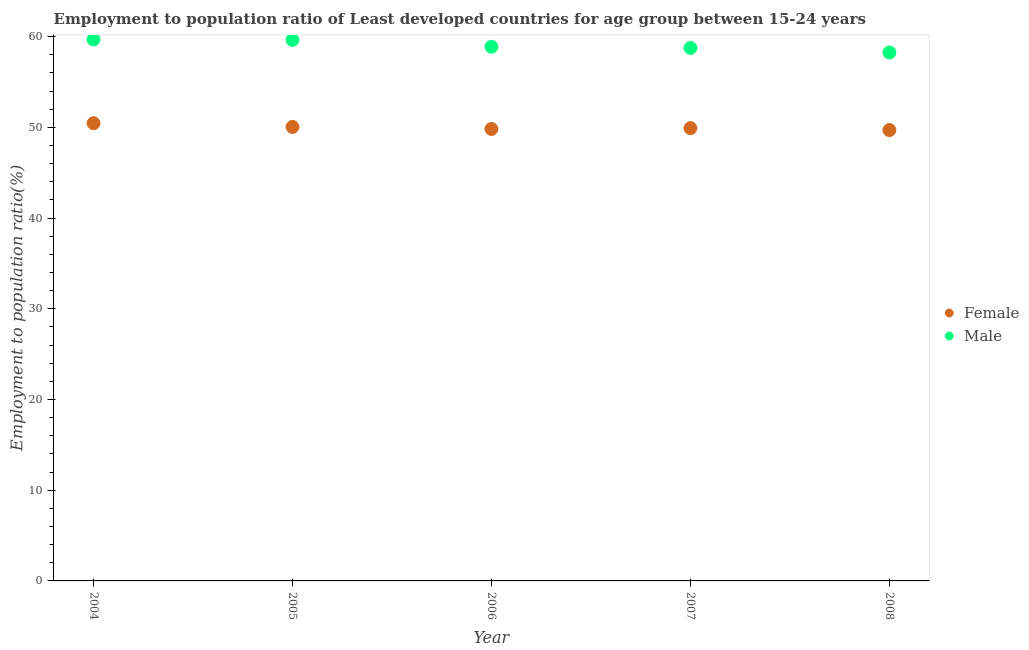How many different coloured dotlines are there?
Provide a succinct answer. 2. Is the number of dotlines equal to the number of legend labels?
Offer a terse response. Yes. What is the employment to population ratio(female) in 2007?
Your answer should be compact. 49.91. Across all years, what is the maximum employment to population ratio(male)?
Your answer should be very brief. 59.69. Across all years, what is the minimum employment to population ratio(female)?
Give a very brief answer. 49.7. What is the total employment to population ratio(female) in the graph?
Keep it short and to the point. 249.92. What is the difference between the employment to population ratio(male) in 2007 and that in 2008?
Give a very brief answer. 0.5. What is the difference between the employment to population ratio(male) in 2004 and the employment to population ratio(female) in 2005?
Keep it short and to the point. 9.65. What is the average employment to population ratio(female) per year?
Offer a terse response. 49.98. In the year 2004, what is the difference between the employment to population ratio(male) and employment to population ratio(female)?
Ensure brevity in your answer.  9.24. What is the ratio of the employment to population ratio(female) in 2004 to that in 2005?
Your answer should be compact. 1.01. Is the employment to population ratio(male) in 2007 less than that in 2008?
Give a very brief answer. No. Is the difference between the employment to population ratio(female) in 2006 and 2008 greater than the difference between the employment to population ratio(male) in 2006 and 2008?
Provide a short and direct response. No. What is the difference between the highest and the second highest employment to population ratio(female)?
Provide a short and direct response. 0.41. What is the difference between the highest and the lowest employment to population ratio(male)?
Give a very brief answer. 1.44. In how many years, is the employment to population ratio(male) greater than the average employment to population ratio(male) taken over all years?
Your response must be concise. 2. Is the employment to population ratio(male) strictly greater than the employment to population ratio(female) over the years?
Your response must be concise. Yes. Is the employment to population ratio(male) strictly less than the employment to population ratio(female) over the years?
Offer a terse response. No. How many dotlines are there?
Make the answer very short. 2. What is the difference between two consecutive major ticks on the Y-axis?
Your answer should be compact. 10. Does the graph contain any zero values?
Provide a short and direct response. No. Does the graph contain grids?
Ensure brevity in your answer.  No. How many legend labels are there?
Ensure brevity in your answer.  2. What is the title of the graph?
Make the answer very short. Employment to population ratio of Least developed countries for age group between 15-24 years. What is the Employment to population ratio(%) of Female in 2004?
Ensure brevity in your answer.  50.45. What is the Employment to population ratio(%) in Male in 2004?
Make the answer very short. 59.69. What is the Employment to population ratio(%) of Female in 2005?
Offer a very short reply. 50.04. What is the Employment to population ratio(%) in Male in 2005?
Provide a succinct answer. 59.64. What is the Employment to population ratio(%) in Female in 2006?
Offer a terse response. 49.82. What is the Employment to population ratio(%) in Male in 2006?
Offer a terse response. 58.88. What is the Employment to population ratio(%) of Female in 2007?
Offer a very short reply. 49.91. What is the Employment to population ratio(%) in Male in 2007?
Your answer should be very brief. 58.75. What is the Employment to population ratio(%) of Female in 2008?
Offer a terse response. 49.7. What is the Employment to population ratio(%) in Male in 2008?
Make the answer very short. 58.25. Across all years, what is the maximum Employment to population ratio(%) of Female?
Provide a short and direct response. 50.45. Across all years, what is the maximum Employment to population ratio(%) of Male?
Ensure brevity in your answer.  59.69. Across all years, what is the minimum Employment to population ratio(%) of Female?
Ensure brevity in your answer.  49.7. Across all years, what is the minimum Employment to population ratio(%) in Male?
Your answer should be compact. 58.25. What is the total Employment to population ratio(%) of Female in the graph?
Provide a succinct answer. 249.92. What is the total Employment to population ratio(%) of Male in the graph?
Provide a succinct answer. 295.2. What is the difference between the Employment to population ratio(%) in Female in 2004 and that in 2005?
Offer a terse response. 0.41. What is the difference between the Employment to population ratio(%) of Male in 2004 and that in 2005?
Offer a terse response. 0.05. What is the difference between the Employment to population ratio(%) of Female in 2004 and that in 2006?
Offer a terse response. 0.63. What is the difference between the Employment to population ratio(%) in Male in 2004 and that in 2006?
Ensure brevity in your answer.  0.81. What is the difference between the Employment to population ratio(%) of Female in 2004 and that in 2007?
Offer a terse response. 0.54. What is the difference between the Employment to population ratio(%) of Female in 2004 and that in 2008?
Offer a very short reply. 0.75. What is the difference between the Employment to population ratio(%) of Male in 2004 and that in 2008?
Offer a very short reply. 1.44. What is the difference between the Employment to population ratio(%) of Female in 2005 and that in 2006?
Keep it short and to the point. 0.22. What is the difference between the Employment to population ratio(%) in Male in 2005 and that in 2006?
Offer a very short reply. 0.76. What is the difference between the Employment to population ratio(%) in Female in 2005 and that in 2007?
Your response must be concise. 0.13. What is the difference between the Employment to population ratio(%) of Male in 2005 and that in 2007?
Your response must be concise. 0.89. What is the difference between the Employment to population ratio(%) in Female in 2005 and that in 2008?
Offer a very short reply. 0.34. What is the difference between the Employment to population ratio(%) of Male in 2005 and that in 2008?
Make the answer very short. 1.4. What is the difference between the Employment to population ratio(%) in Female in 2006 and that in 2007?
Make the answer very short. -0.09. What is the difference between the Employment to population ratio(%) in Male in 2006 and that in 2007?
Offer a very short reply. 0.13. What is the difference between the Employment to population ratio(%) in Female in 2006 and that in 2008?
Offer a very short reply. 0.12. What is the difference between the Employment to population ratio(%) of Male in 2006 and that in 2008?
Provide a succinct answer. 0.63. What is the difference between the Employment to population ratio(%) of Female in 2007 and that in 2008?
Provide a short and direct response. 0.21. What is the difference between the Employment to population ratio(%) of Male in 2007 and that in 2008?
Your answer should be compact. 0.5. What is the difference between the Employment to population ratio(%) in Female in 2004 and the Employment to population ratio(%) in Male in 2005?
Ensure brevity in your answer.  -9.19. What is the difference between the Employment to population ratio(%) of Female in 2004 and the Employment to population ratio(%) of Male in 2006?
Ensure brevity in your answer.  -8.43. What is the difference between the Employment to population ratio(%) in Female in 2004 and the Employment to population ratio(%) in Male in 2007?
Offer a terse response. -8.3. What is the difference between the Employment to population ratio(%) in Female in 2004 and the Employment to population ratio(%) in Male in 2008?
Your answer should be very brief. -7.8. What is the difference between the Employment to population ratio(%) of Female in 2005 and the Employment to population ratio(%) of Male in 2006?
Your answer should be very brief. -8.84. What is the difference between the Employment to population ratio(%) in Female in 2005 and the Employment to population ratio(%) in Male in 2007?
Make the answer very short. -8.71. What is the difference between the Employment to population ratio(%) in Female in 2005 and the Employment to population ratio(%) in Male in 2008?
Provide a short and direct response. -8.2. What is the difference between the Employment to population ratio(%) of Female in 2006 and the Employment to population ratio(%) of Male in 2007?
Give a very brief answer. -8.93. What is the difference between the Employment to population ratio(%) in Female in 2006 and the Employment to population ratio(%) in Male in 2008?
Your answer should be compact. -8.43. What is the difference between the Employment to population ratio(%) of Female in 2007 and the Employment to population ratio(%) of Male in 2008?
Provide a succinct answer. -8.34. What is the average Employment to population ratio(%) in Female per year?
Ensure brevity in your answer.  49.98. What is the average Employment to population ratio(%) in Male per year?
Your answer should be compact. 59.04. In the year 2004, what is the difference between the Employment to population ratio(%) in Female and Employment to population ratio(%) in Male?
Your answer should be very brief. -9.24. In the year 2005, what is the difference between the Employment to population ratio(%) of Female and Employment to population ratio(%) of Male?
Offer a terse response. -9.6. In the year 2006, what is the difference between the Employment to population ratio(%) of Female and Employment to population ratio(%) of Male?
Make the answer very short. -9.06. In the year 2007, what is the difference between the Employment to population ratio(%) in Female and Employment to population ratio(%) in Male?
Offer a terse response. -8.84. In the year 2008, what is the difference between the Employment to population ratio(%) of Female and Employment to population ratio(%) of Male?
Give a very brief answer. -8.55. What is the ratio of the Employment to population ratio(%) of Female in 2004 to that in 2005?
Your answer should be compact. 1.01. What is the ratio of the Employment to population ratio(%) in Male in 2004 to that in 2005?
Offer a very short reply. 1. What is the ratio of the Employment to population ratio(%) of Female in 2004 to that in 2006?
Provide a short and direct response. 1.01. What is the ratio of the Employment to population ratio(%) in Male in 2004 to that in 2006?
Your answer should be compact. 1.01. What is the ratio of the Employment to population ratio(%) in Female in 2004 to that in 2007?
Your answer should be compact. 1.01. What is the ratio of the Employment to population ratio(%) of Female in 2004 to that in 2008?
Your answer should be very brief. 1.02. What is the ratio of the Employment to population ratio(%) in Male in 2004 to that in 2008?
Offer a terse response. 1.02. What is the ratio of the Employment to population ratio(%) of Female in 2005 to that in 2006?
Keep it short and to the point. 1. What is the ratio of the Employment to population ratio(%) of Male in 2005 to that in 2006?
Provide a succinct answer. 1.01. What is the ratio of the Employment to population ratio(%) of Male in 2005 to that in 2007?
Your answer should be compact. 1.02. What is the ratio of the Employment to population ratio(%) of Male in 2005 to that in 2008?
Your answer should be compact. 1.02. What is the ratio of the Employment to population ratio(%) of Female in 2006 to that in 2008?
Offer a very short reply. 1. What is the ratio of the Employment to population ratio(%) of Male in 2006 to that in 2008?
Provide a succinct answer. 1.01. What is the ratio of the Employment to population ratio(%) of Female in 2007 to that in 2008?
Make the answer very short. 1. What is the ratio of the Employment to population ratio(%) in Male in 2007 to that in 2008?
Your answer should be very brief. 1.01. What is the difference between the highest and the second highest Employment to population ratio(%) of Female?
Provide a succinct answer. 0.41. What is the difference between the highest and the second highest Employment to population ratio(%) in Male?
Offer a very short reply. 0.05. What is the difference between the highest and the lowest Employment to population ratio(%) in Female?
Provide a succinct answer. 0.75. What is the difference between the highest and the lowest Employment to population ratio(%) in Male?
Give a very brief answer. 1.44. 